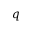Convert formula to latex. <formula><loc_0><loc_0><loc_500><loc_500>q</formula> 